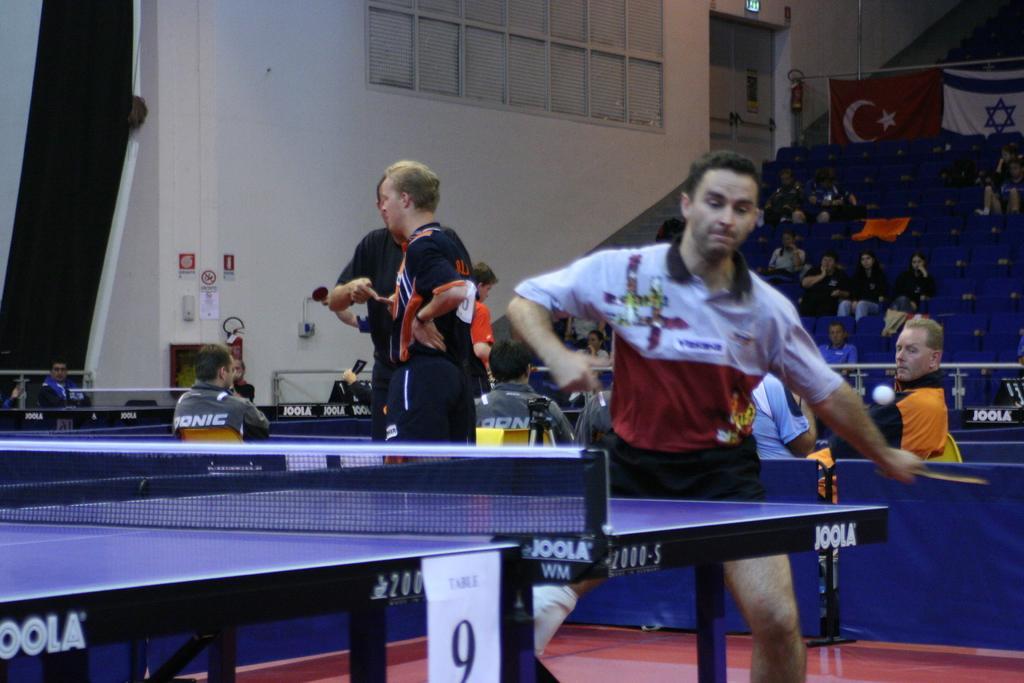Please provide a concise description of this image. In this image i can see a man standing and playing at left there are two other persons standing and a man sitting at the back ground i can see few other people sitting on a chair, a banner, at left i can see a wall, a window. 